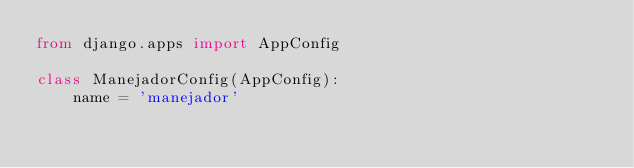Convert code to text. <code><loc_0><loc_0><loc_500><loc_500><_Python_>from django.apps import AppConfig

class ManejadorConfig(AppConfig):
    name = 'manejador'
    
    </code> 